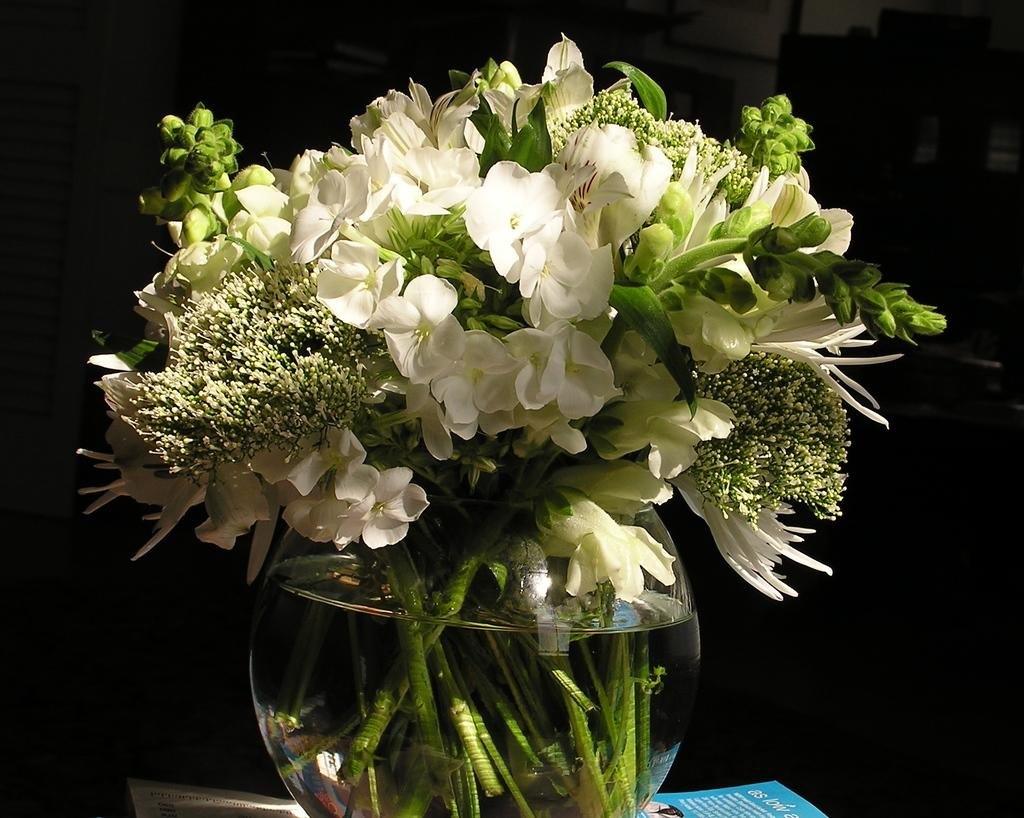What type of plants are in the image? There are flowers in the image. How are the flowers arranged or displayed? The flowers are on a glass pot. Can you describe the container holding the flowers? The glass pot has water visible on it. What type of stove can be seen in the background of the image? There is no stove present in the image; it features flowers on a glass pot with water. 